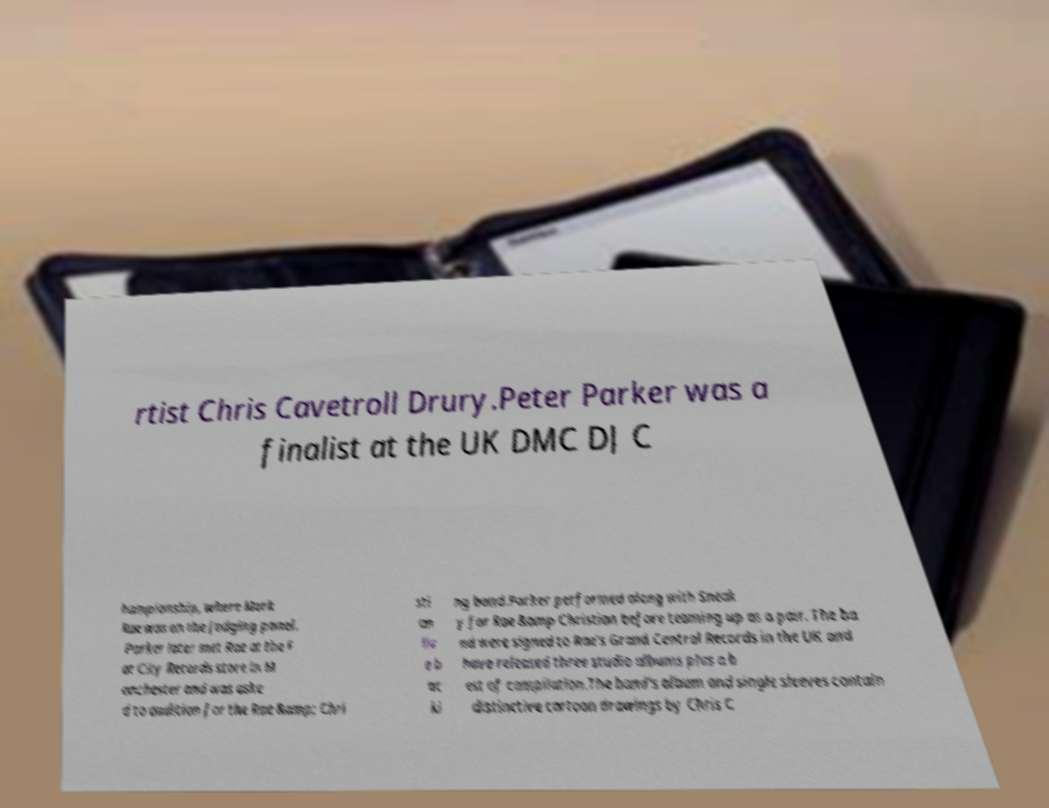Please identify and transcribe the text found in this image. rtist Chris Cavetroll Drury.Peter Parker was a finalist at the UK DMC DJ C hampionship, where Mark Rae was on the judging panel. Parker later met Rae at the F at City Records store in M anchester and was aske d to audition for the Rae &amp; Chri sti an liv e b ac ki ng band.Parker performed along with Sneak y for Rae &amp Christian before teaming up as a pair. The ba nd were signed to Rae's Grand Central Records in the UK and have released three studio albums plus a b est of compilation.The band's album and single sleeves contain distinctive cartoon drawings by Chris C 